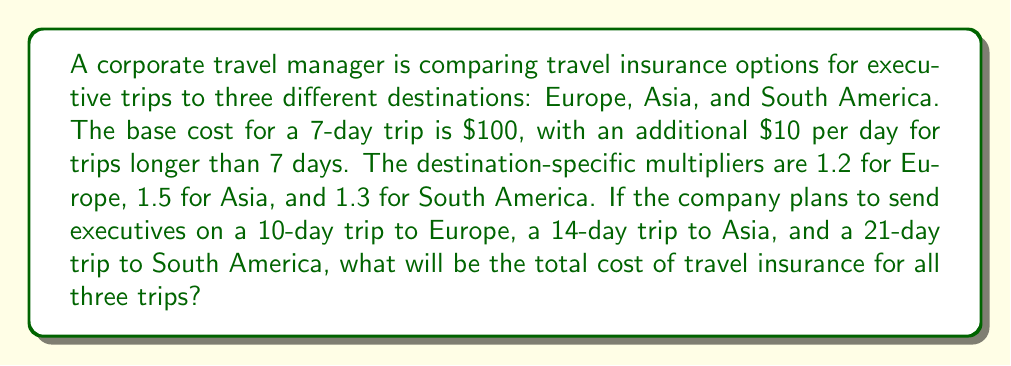Can you solve this math problem? Let's break this down step-by-step:

1. Calculate the cost for the Europe trip (10 days):
   Base cost: $100
   Additional days: 3 × $10 = $30
   Subtotal: $100 + $30 = $130
   Apply Europe multiplier: $130 × 1.2 = $156

2. Calculate the cost for the Asia trip (14 days):
   Base cost: $100
   Additional days: 7 × $10 = $70
   Subtotal: $100 + $70 = $170
   Apply Asia multiplier: $170 × 1.5 = $255

3. Calculate the cost for the South America trip (21 days):
   Base cost: $100
   Additional days: 14 × $10 = $140
   Subtotal: $100 + $140 = $240
   Apply South America multiplier: $240 × 1.3 = $312

4. Sum up the costs for all three trips:
   Total cost = Europe trip + Asia trip + South America trip
   Total cost = $156 + $255 + $312 = $723

The calculation can be expressed mathematically as:

$$\text{Total Cost} = \sum_{i=1}^{3} (100 + \max(0, d_i - 7) \times 10) \times m_i$$

Where:
$d_i$ is the duration of trip $i$ in days
$m_i$ is the destination-specific multiplier for trip $i$
Answer: $723 